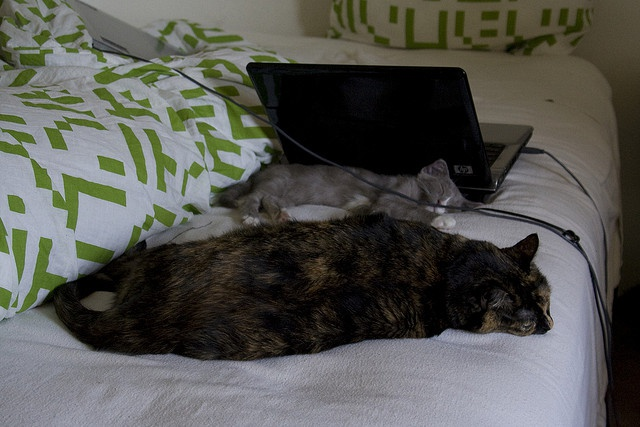Describe the objects in this image and their specific colors. I can see bed in darkgreen, gray, and darkgray tones, cat in darkgreen, black, and gray tones, bed in darkgreen, gray, and black tones, laptop in darkgreen, black, and gray tones, and cat in darkgreen, black, and gray tones in this image. 